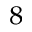Convert formula to latex. <formula><loc_0><loc_0><loc_500><loc_500>^ { 8 }</formula> 